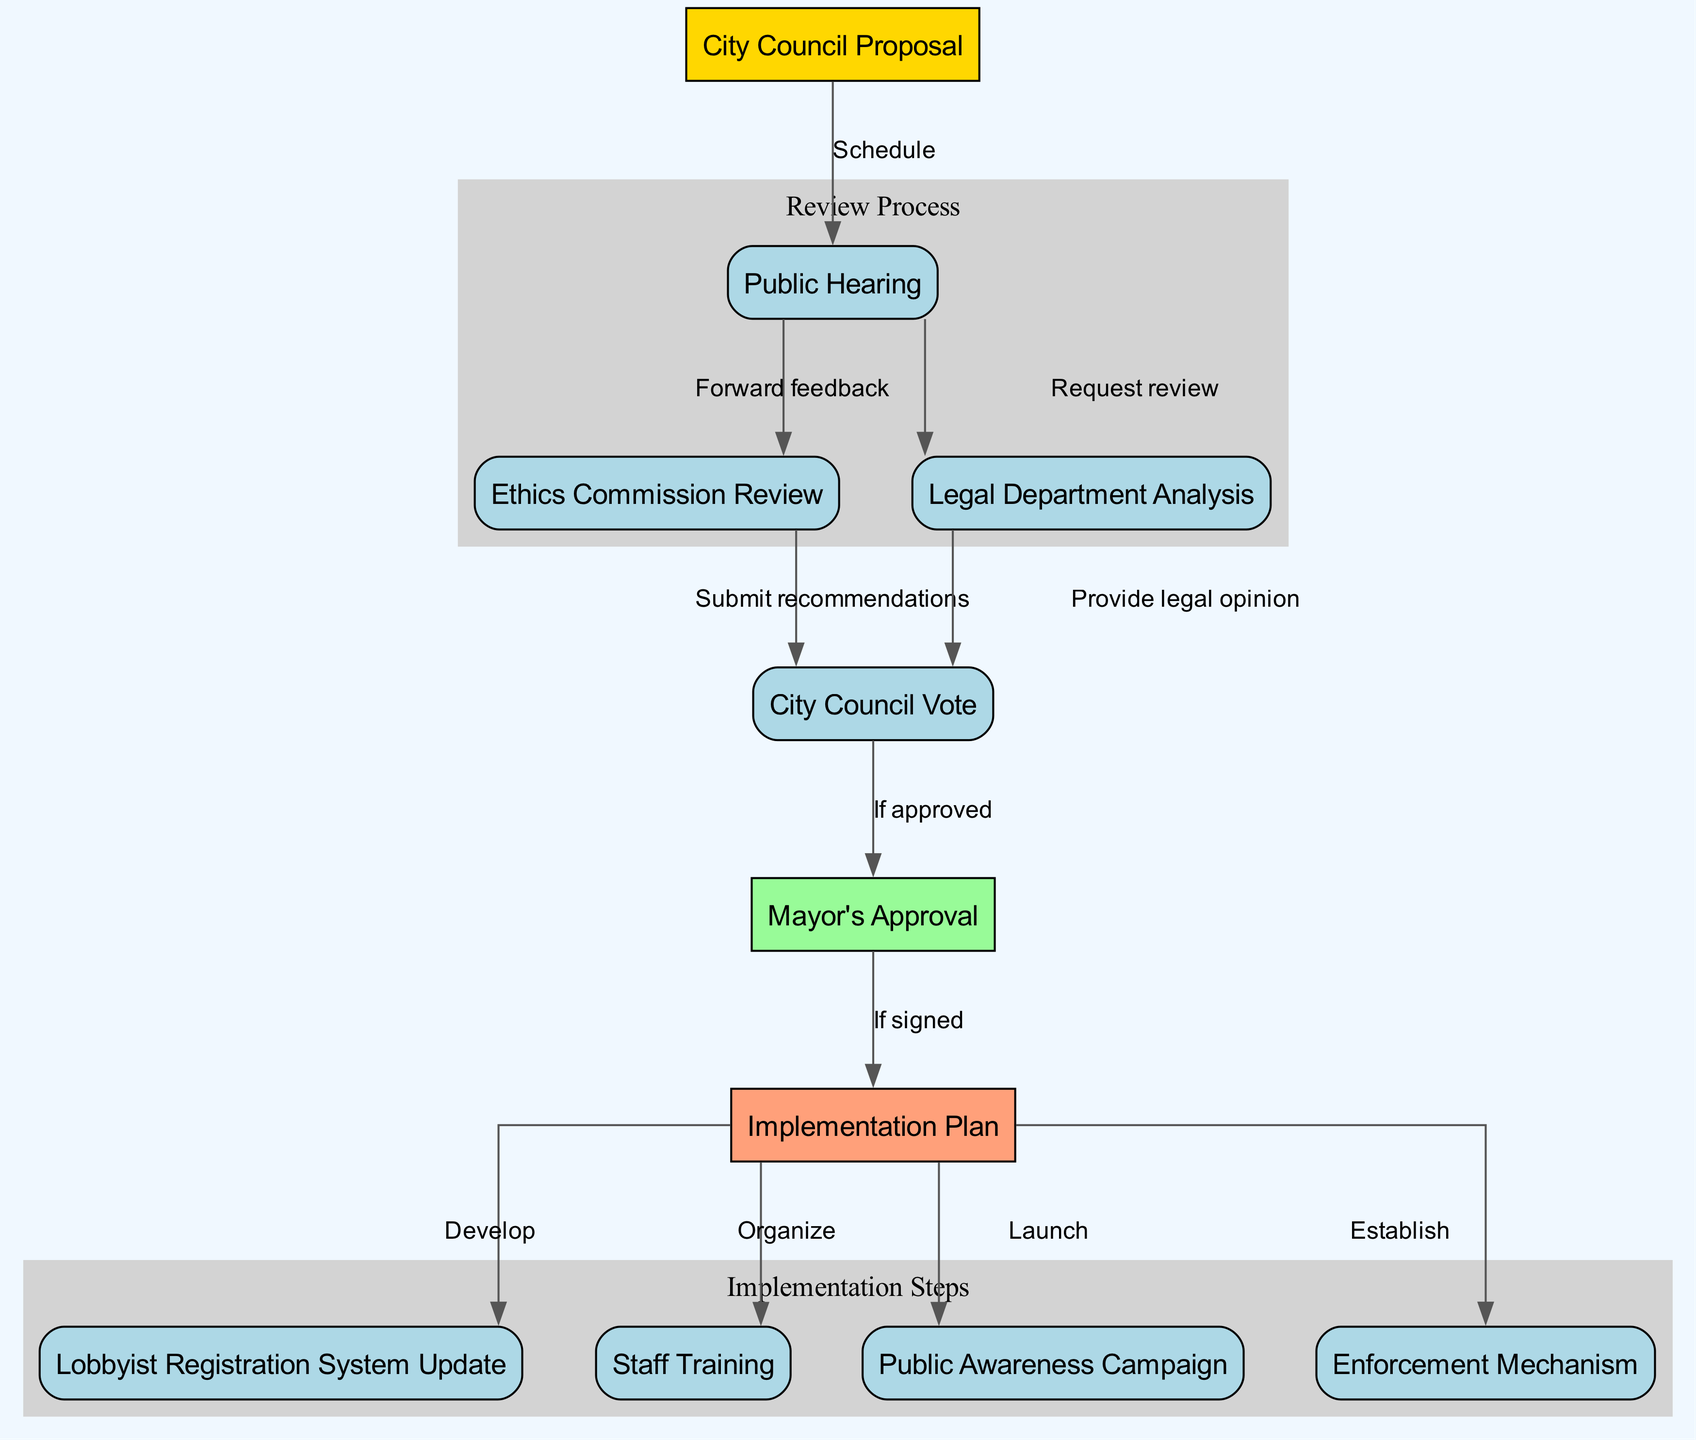What is the first step in the process? The diagram indicates that the first step in the process is the "City Council Proposal," which is the initial node before any action is taken.
Answer: City Council Proposal How many nodes are there in the diagram? By counting the unique nodes listed in the diagram, we find there are a total of eleven nodes that represent various steps and actions in the lobbyist registration process.
Answer: Eleven What action occurs after the Public Hearing? The diagram shows that after the Public Hearing, feedback is forwarded to the Ethics Commission for review, making that the next step after public involvement.
Answer: Forward feedback What needs to happen before the City Council can vote? The diagram indicates that before the City Council can vote, recommendations from the Ethics Commission and the legal opinion from the Legal Department must both be submitted as these are prerequisites for the vote.
Answer: Submit recommendations and provide legal opinion What happens if the Mayor approves the proposal? According to the flowchart, if the Mayor approves the proposal, it leads to the development of an Implementation Plan, marked by the next step after approval.
Answer: Implementation Plan Which nodes are grouped under the Review Process? The diagram groups the nodes for the Public Hearing, Ethics Commission Review, and Legal Department Analysis under the label "Review Process," indicating these steps are interconnected.
Answer: Public Hearing, Ethics Commission Review, Legal Department Analysis Which action follows the Implementation Plan? Following the Implementation Plan, the diagram outlines that the next actions include updating the Lobbyist Registration System, organizing Staff Training, launching a Public Awareness Campaign, and establishing an Enforcement Mechanism.
Answer: Lobbyist Registration System Update, Staff Training, Public Awareness Campaign, Enforcement Mechanism How are the related nodes visually distinguished in the diagram? The related nodes for the Review Process and Implementation Steps are visually distinguished by being placed in separate clusters labeled "Review Process" and "Implementation Steps," with a grey background that indicates a grouping.
Answer: Clusters labeled "Review Process" and "Implementation Steps" What condition leads to the Mayor's approval? The diagram specifies that the condition for the Mayor's approval follows a successful vote by the City Council, indicating the decision must come from the council first before reaching the mayor.
Answer: If approved 